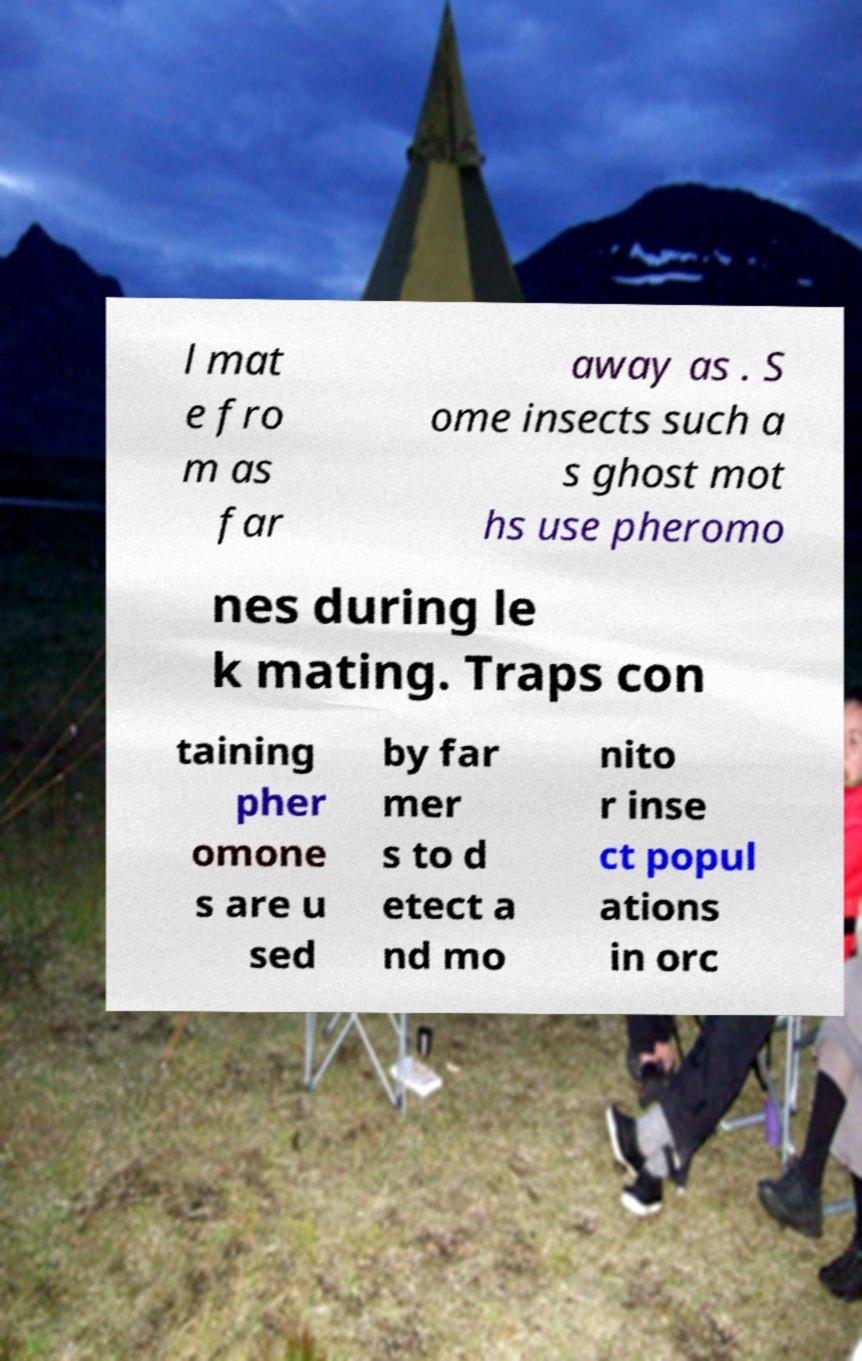There's text embedded in this image that I need extracted. Can you transcribe it verbatim? l mat e fro m as far away as . S ome insects such a s ghost mot hs use pheromo nes during le k mating. Traps con taining pher omone s are u sed by far mer s to d etect a nd mo nito r inse ct popul ations in orc 